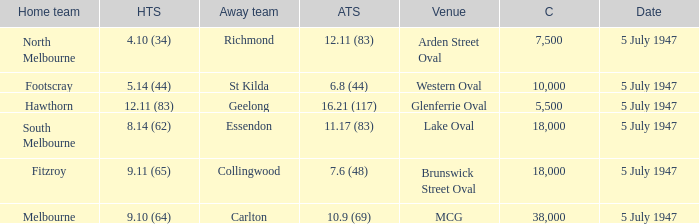What did the home team score when the away team scored 12.11 (83)? 4.10 (34). Would you mind parsing the complete table? {'header': ['Home team', 'HTS', 'Away team', 'ATS', 'Venue', 'C', 'Date'], 'rows': [['North Melbourne', '4.10 (34)', 'Richmond', '12.11 (83)', 'Arden Street Oval', '7,500', '5 July 1947'], ['Footscray', '5.14 (44)', 'St Kilda', '6.8 (44)', 'Western Oval', '10,000', '5 July 1947'], ['Hawthorn', '12.11 (83)', 'Geelong', '16.21 (117)', 'Glenferrie Oval', '5,500', '5 July 1947'], ['South Melbourne', '8.14 (62)', 'Essendon', '11.17 (83)', 'Lake Oval', '18,000', '5 July 1947'], ['Fitzroy', '9.11 (65)', 'Collingwood', '7.6 (48)', 'Brunswick Street Oval', '18,000', '5 July 1947'], ['Melbourne', '9.10 (64)', 'Carlton', '10.9 (69)', 'MCG', '38,000', '5 July 1947']]} 